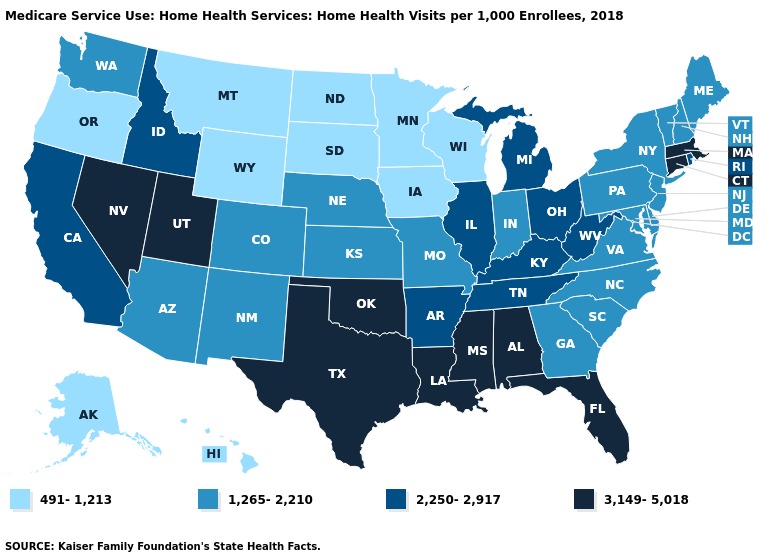Which states have the lowest value in the USA?
Answer briefly. Alaska, Hawaii, Iowa, Minnesota, Montana, North Dakota, Oregon, South Dakota, Wisconsin, Wyoming. Does West Virginia have the same value as California?
Quick response, please. Yes. Name the states that have a value in the range 3,149-5,018?
Give a very brief answer. Alabama, Connecticut, Florida, Louisiana, Massachusetts, Mississippi, Nevada, Oklahoma, Texas, Utah. Which states have the lowest value in the USA?
Keep it brief. Alaska, Hawaii, Iowa, Minnesota, Montana, North Dakota, Oregon, South Dakota, Wisconsin, Wyoming. Which states hav the highest value in the Northeast?
Write a very short answer. Connecticut, Massachusetts. What is the highest value in states that border Minnesota?
Answer briefly. 491-1,213. What is the highest value in the USA?
Quick response, please. 3,149-5,018. Does North Dakota have a lower value than South Dakota?
Concise answer only. No. Name the states that have a value in the range 3,149-5,018?
Keep it brief. Alabama, Connecticut, Florida, Louisiana, Massachusetts, Mississippi, Nevada, Oklahoma, Texas, Utah. What is the highest value in the Northeast ?
Give a very brief answer. 3,149-5,018. What is the highest value in the USA?
Answer briefly. 3,149-5,018. Is the legend a continuous bar?
Quick response, please. No. What is the value of New Jersey?
Be succinct. 1,265-2,210. What is the value of Wyoming?
Answer briefly. 491-1,213. What is the highest value in the West ?
Write a very short answer. 3,149-5,018. 